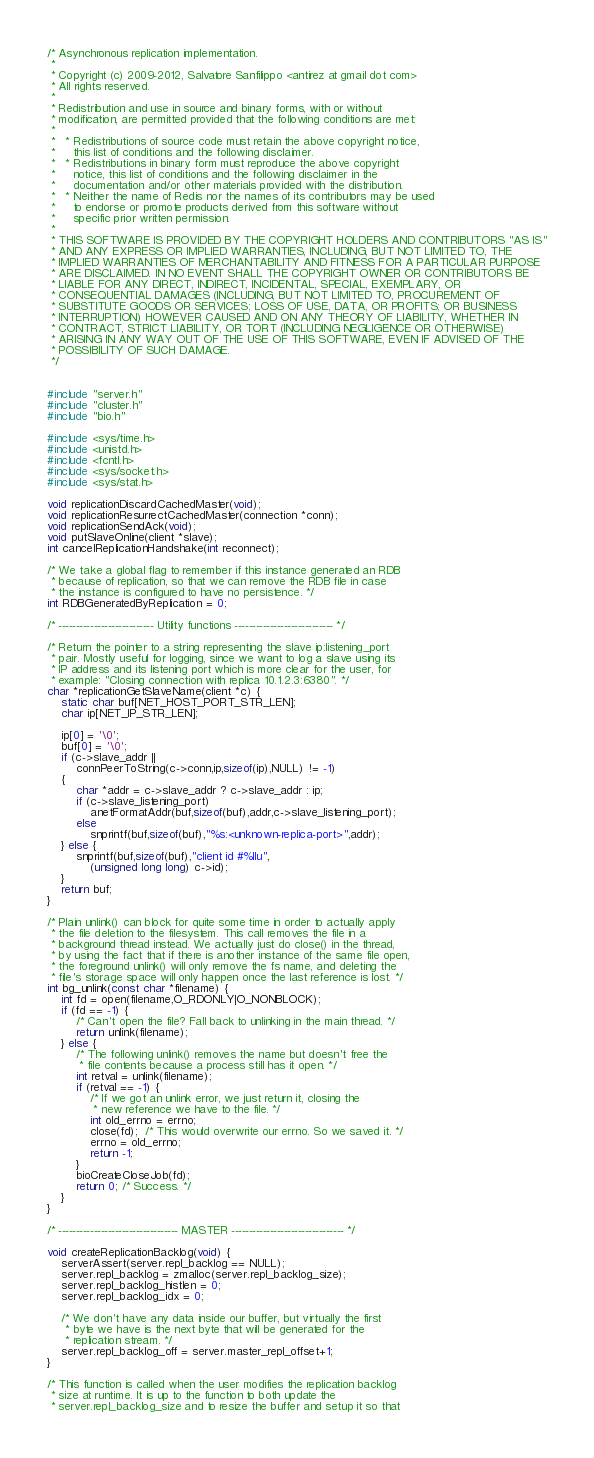<code> <loc_0><loc_0><loc_500><loc_500><_C_>/* Asynchronous replication implementation.
 *
 * Copyright (c) 2009-2012, Salvatore Sanfilippo <antirez at gmail dot com>
 * All rights reserved.
 *
 * Redistribution and use in source and binary forms, with or without
 * modification, are permitted provided that the following conditions are met:
 *
 *   * Redistributions of source code must retain the above copyright notice,
 *     this list of conditions and the following disclaimer.
 *   * Redistributions in binary form must reproduce the above copyright
 *     notice, this list of conditions and the following disclaimer in the
 *     documentation and/or other materials provided with the distribution.
 *   * Neither the name of Redis nor the names of its contributors may be used
 *     to endorse or promote products derived from this software without
 *     specific prior written permission.
 *
 * THIS SOFTWARE IS PROVIDED BY THE COPYRIGHT HOLDERS AND CONTRIBUTORS "AS IS"
 * AND ANY EXPRESS OR IMPLIED WARRANTIES, INCLUDING, BUT NOT LIMITED TO, THE
 * IMPLIED WARRANTIES OF MERCHANTABILITY AND FITNESS FOR A PARTICULAR PURPOSE
 * ARE DISCLAIMED. IN NO EVENT SHALL THE COPYRIGHT OWNER OR CONTRIBUTORS BE
 * LIABLE FOR ANY DIRECT, INDIRECT, INCIDENTAL, SPECIAL, EXEMPLARY, OR
 * CONSEQUENTIAL DAMAGES (INCLUDING, BUT NOT LIMITED TO, PROCUREMENT OF
 * SUBSTITUTE GOODS OR SERVICES; LOSS OF USE, DATA, OR PROFITS; OR BUSINESS
 * INTERRUPTION) HOWEVER CAUSED AND ON ANY THEORY OF LIABILITY, WHETHER IN
 * CONTRACT, STRICT LIABILITY, OR TORT (INCLUDING NEGLIGENCE OR OTHERWISE)
 * ARISING IN ANY WAY OUT OF THE USE OF THIS SOFTWARE, EVEN IF ADVISED OF THE
 * POSSIBILITY OF SUCH DAMAGE.
 */


#include "server.h"
#include "cluster.h"
#include "bio.h"

#include <sys/time.h>
#include <unistd.h>
#include <fcntl.h>
#include <sys/socket.h>
#include <sys/stat.h>

void replicationDiscardCachedMaster(void);
void replicationResurrectCachedMaster(connection *conn);
void replicationSendAck(void);
void putSlaveOnline(client *slave);
int cancelReplicationHandshake(int reconnect);

/* We take a global flag to remember if this instance generated an RDB
 * because of replication, so that we can remove the RDB file in case
 * the instance is configured to have no persistence. */
int RDBGeneratedByReplication = 0;

/* --------------------------- Utility functions ---------------------------- */

/* Return the pointer to a string representing the slave ip:listening_port
 * pair. Mostly useful for logging, since we want to log a slave using its
 * IP address and its listening port which is more clear for the user, for
 * example: "Closing connection with replica 10.1.2.3:6380". */
char *replicationGetSlaveName(client *c) {
    static char buf[NET_HOST_PORT_STR_LEN];
    char ip[NET_IP_STR_LEN];

    ip[0] = '\0';
    buf[0] = '\0';
    if (c->slave_addr ||
        connPeerToString(c->conn,ip,sizeof(ip),NULL) != -1)
    {
        char *addr = c->slave_addr ? c->slave_addr : ip;
        if (c->slave_listening_port)
            anetFormatAddr(buf,sizeof(buf),addr,c->slave_listening_port);
        else
            snprintf(buf,sizeof(buf),"%s:<unknown-replica-port>",addr);
    } else {
        snprintf(buf,sizeof(buf),"client id #%llu",
            (unsigned long long) c->id);
    }
    return buf;
}

/* Plain unlink() can block for quite some time in order to actually apply
 * the file deletion to the filesystem. This call removes the file in a
 * background thread instead. We actually just do close() in the thread,
 * by using the fact that if there is another instance of the same file open,
 * the foreground unlink() will only remove the fs name, and deleting the
 * file's storage space will only happen once the last reference is lost. */
int bg_unlink(const char *filename) {
    int fd = open(filename,O_RDONLY|O_NONBLOCK);
    if (fd == -1) {
        /* Can't open the file? Fall back to unlinking in the main thread. */
        return unlink(filename);
    } else {
        /* The following unlink() removes the name but doesn't free the
         * file contents because a process still has it open. */
        int retval = unlink(filename);
        if (retval == -1) {
            /* If we got an unlink error, we just return it, closing the
             * new reference we have to the file. */
            int old_errno = errno;
            close(fd);  /* This would overwrite our errno. So we saved it. */
            errno = old_errno;
            return -1;
        }
        bioCreateCloseJob(fd);
        return 0; /* Success. */
    }
}

/* ---------------------------------- MASTER -------------------------------- */

void createReplicationBacklog(void) {
    serverAssert(server.repl_backlog == NULL);
    server.repl_backlog = zmalloc(server.repl_backlog_size);
    server.repl_backlog_histlen = 0;
    server.repl_backlog_idx = 0;

    /* We don't have any data inside our buffer, but virtually the first
     * byte we have is the next byte that will be generated for the
     * replication stream. */
    server.repl_backlog_off = server.master_repl_offset+1;
}

/* This function is called when the user modifies the replication backlog
 * size at runtime. It is up to the function to both update the
 * server.repl_backlog_size and to resize the buffer and setup it so that</code> 